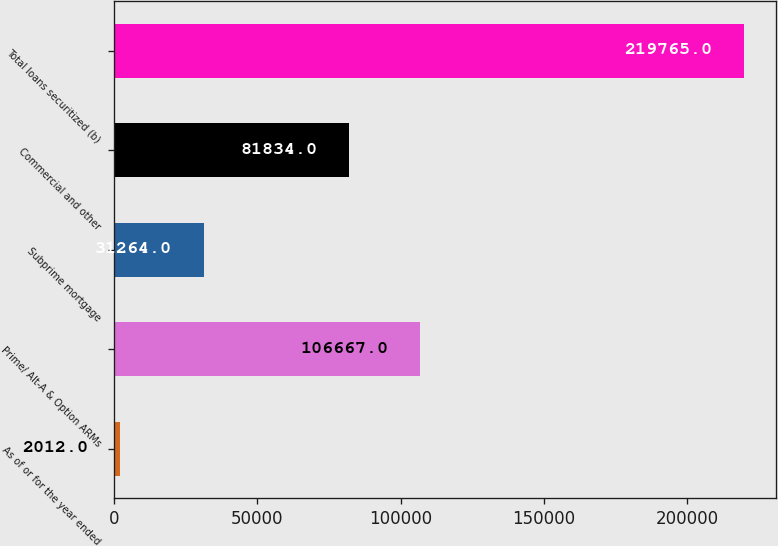Convert chart to OTSL. <chart><loc_0><loc_0><loc_500><loc_500><bar_chart><fcel>As of or for the year ended<fcel>Prime/ Alt-A & Option ARMs<fcel>Subprime mortgage<fcel>Commercial and other<fcel>Total loans securitized (b)<nl><fcel>2012<fcel>106667<fcel>31264<fcel>81834<fcel>219765<nl></chart> 